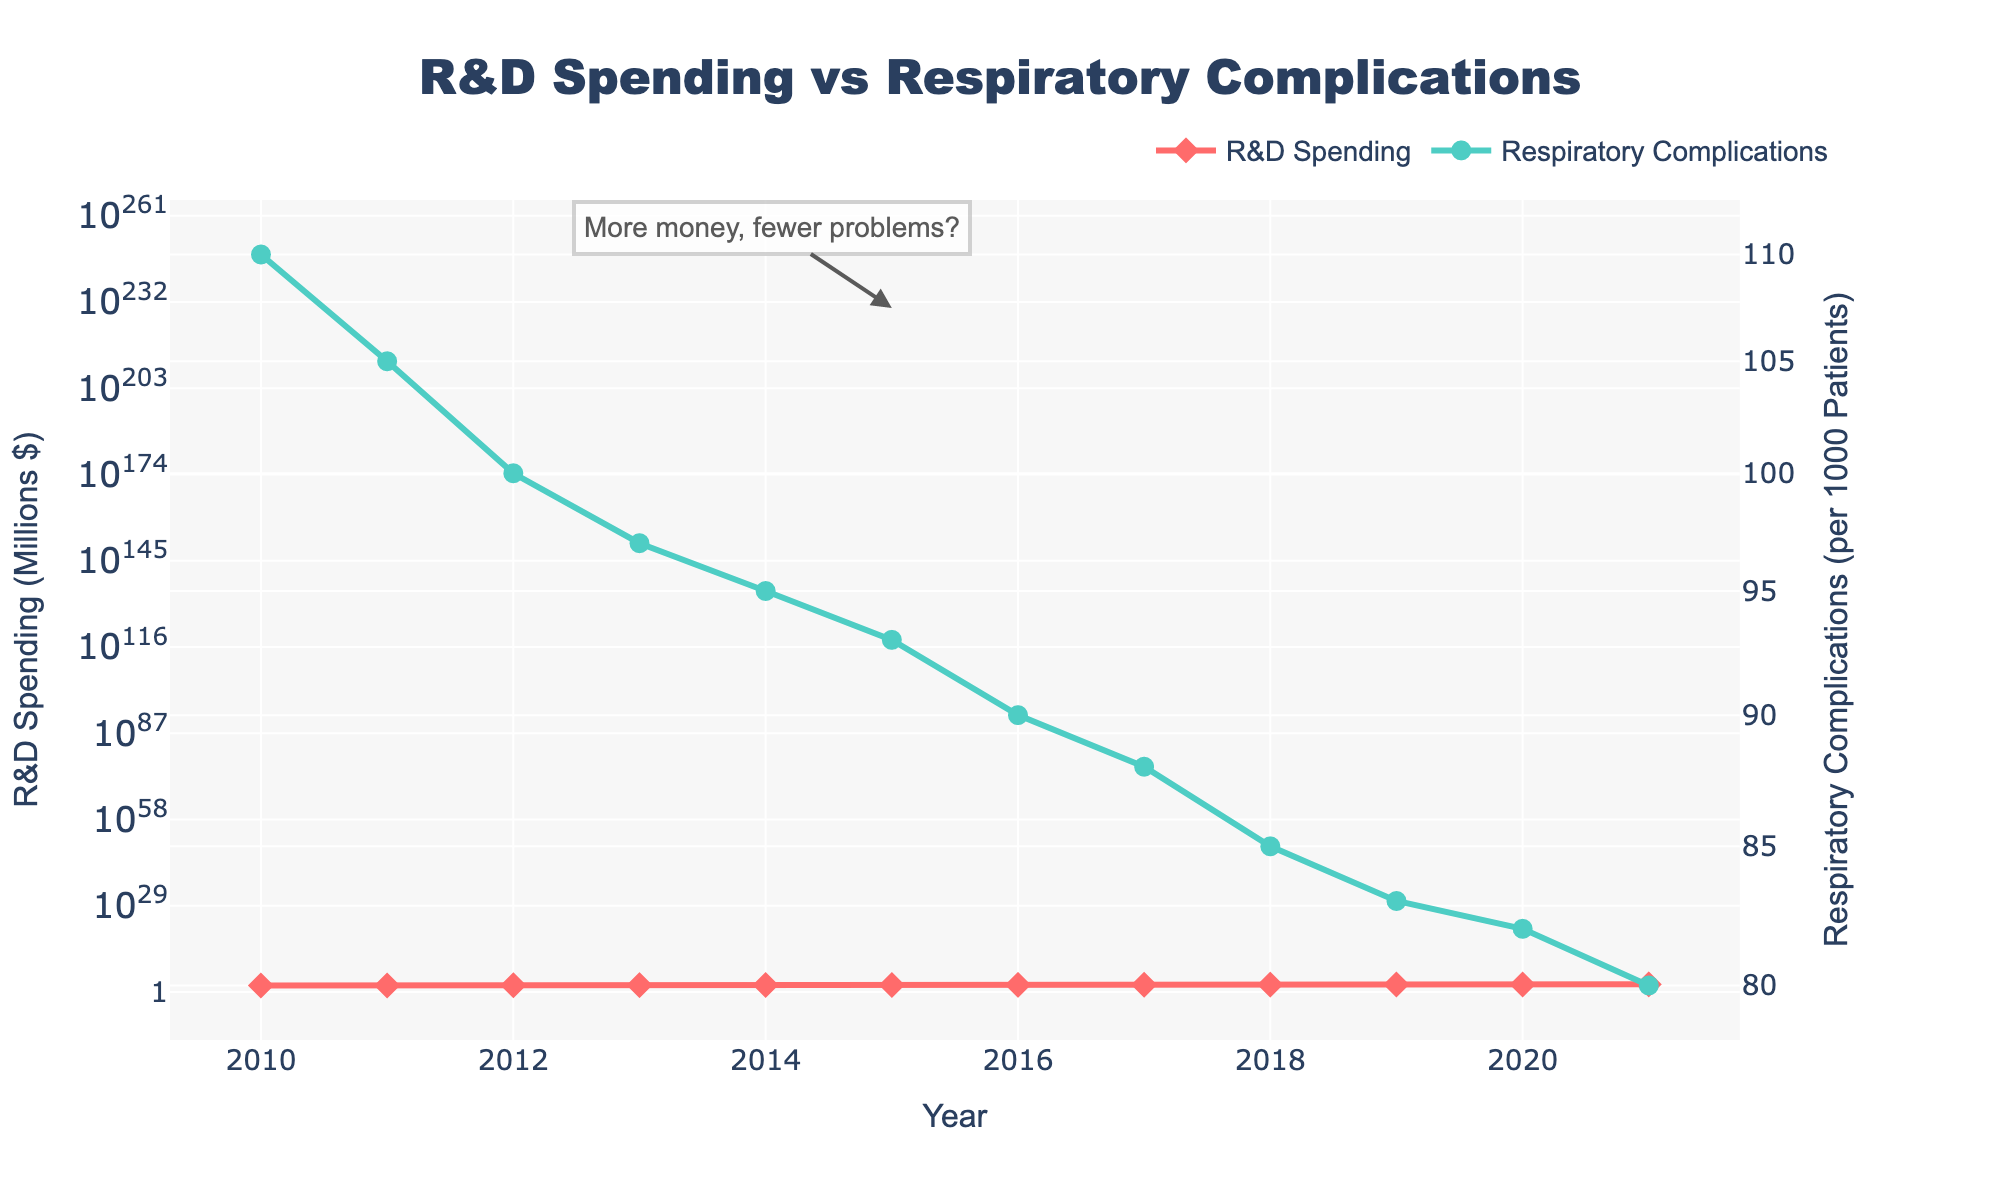What's the title of the plot? The plot's title is given at the top, and it states, "R&D Spending vs Respiratory Complications".
Answer: R&D Spending vs Respiratory Complications How many years of data are represented in the plot? The plot shows data points from the x-axis, which is labeled as "Year", starting from 2010 up to 2021. Counting these, we have 12 years of data.
Answer: 12 What trend is observed in R&D Spending over the years? The line representing R&D Spending shows an upward trend from 2010 to 2021, indicating that R&D Spending has been increasing over this period.
Answer: Increasing How does the incidence of respiratory complications change as R&D spending increases? By observing both lines together, R&D Spending increases and the incidence of respiratory complications decreases, showing a negative relationship between the two variables.
Answer: Decreases What's the difference in R&D Spending between the years 2015 and 2018? In 2015, R&D Spending is $230 million; in 2018, it is $300 million. The difference is $300M - $230M = $70M.
Answer: $70M Which year witnessed the highest incidence of respiratory complications, and what was the R&D spending in that year? The year 2010 shows the highest incidence of respiratory complications at 110 per 1000 patients, and R&D Spending in that year was $150 million.
Answer: 2010, $150M What is the percentage reduction in the incidence of respiratory complications from 2010 to 2021? The incidence in 2010 was 110 per 1000 patients, and in 2021, it was 80 per 1000 patients. The reduction is 110 - 80 = 30. The percentage reduction is (30/110) * 100% = 27.27%.
Answer: 27.27% How many years after 2010 did the R&D Spending reach $300 million? R&D Spending reached $300 million in 2018. Counting from 2010 to 2018, it took 8 years.
Answer: 8 years Between which consecutive years did the R&D Spending show the greatest increase? Observing the year-over-year changes, the jump from 2017 to 2018 (from $270 million to $300 million) shows the largest increase of $30 million.
Answer: Between 2017 and 2018 